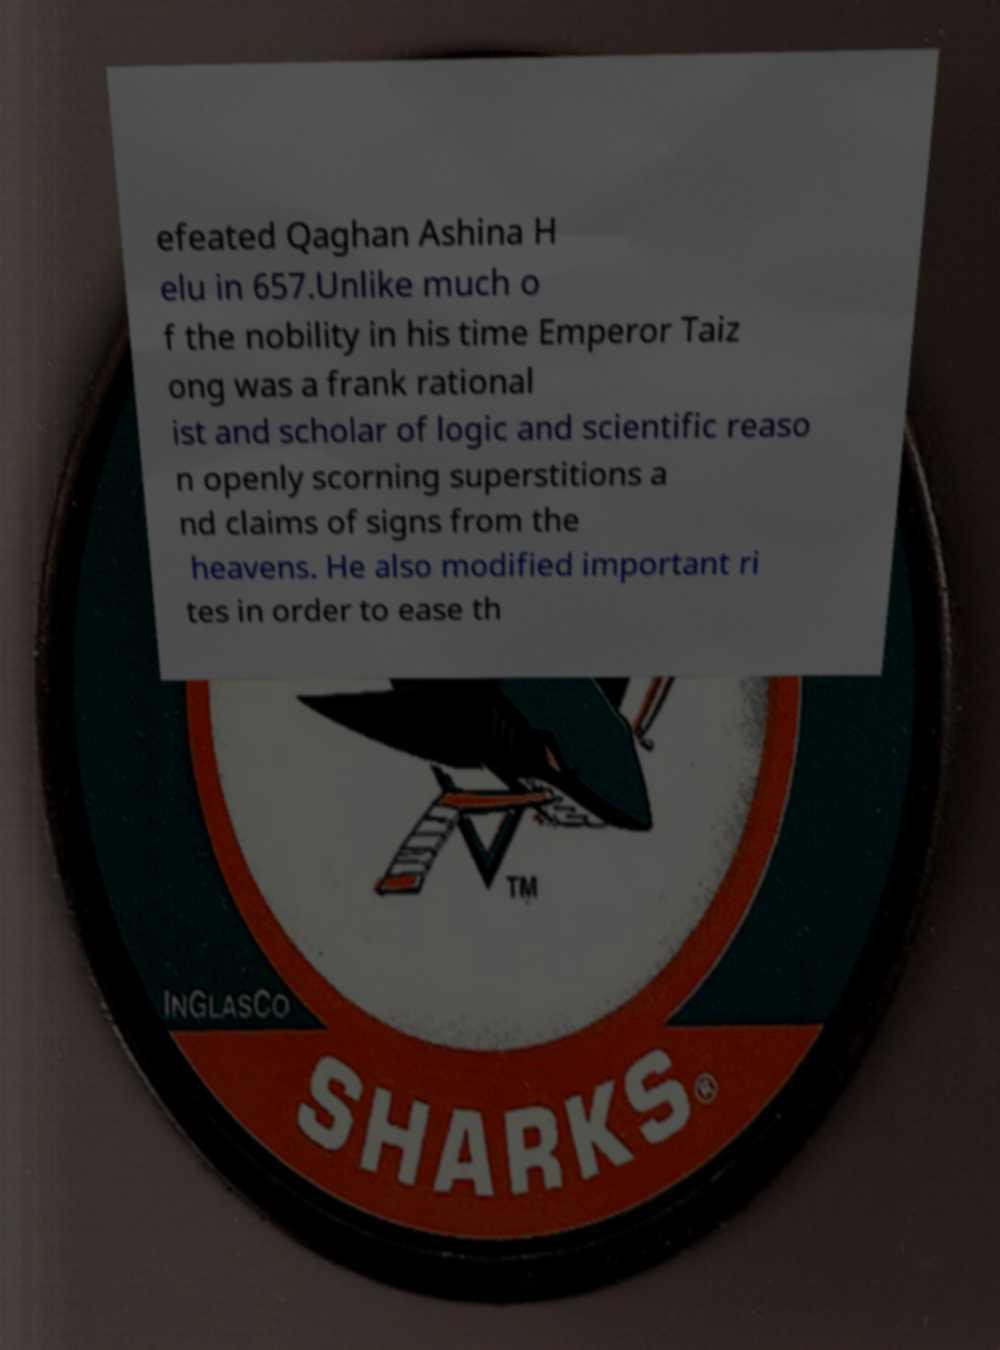Please read and relay the text visible in this image. What does it say? efeated Qaghan Ashina H elu in 657.Unlike much o f the nobility in his time Emperor Taiz ong was a frank rational ist and scholar of logic and scientific reaso n openly scorning superstitions a nd claims of signs from the heavens. He also modified important ri tes in order to ease th 